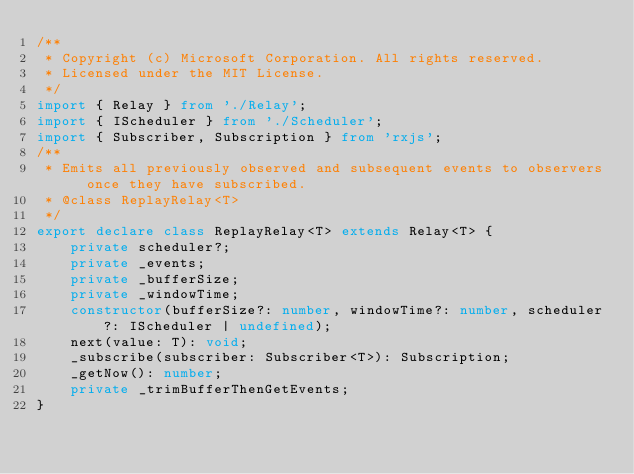<code> <loc_0><loc_0><loc_500><loc_500><_TypeScript_>/**
 * Copyright (c) Microsoft Corporation. All rights reserved.
 * Licensed under the MIT License.
 */
import { Relay } from './Relay';
import { IScheduler } from './Scheduler';
import { Subscriber, Subscription } from 'rxjs';
/**
 * Emits all previously observed and subsequent events to observers once they have subscribed.
 * @class ReplayRelay<T>
 */
export declare class ReplayRelay<T> extends Relay<T> {
    private scheduler?;
    private _events;
    private _bufferSize;
    private _windowTime;
    constructor(bufferSize?: number, windowTime?: number, scheduler?: IScheduler | undefined);
    next(value: T): void;
    _subscribe(subscriber: Subscriber<T>): Subscription;
    _getNow(): number;
    private _trimBufferThenGetEvents;
}
</code> 